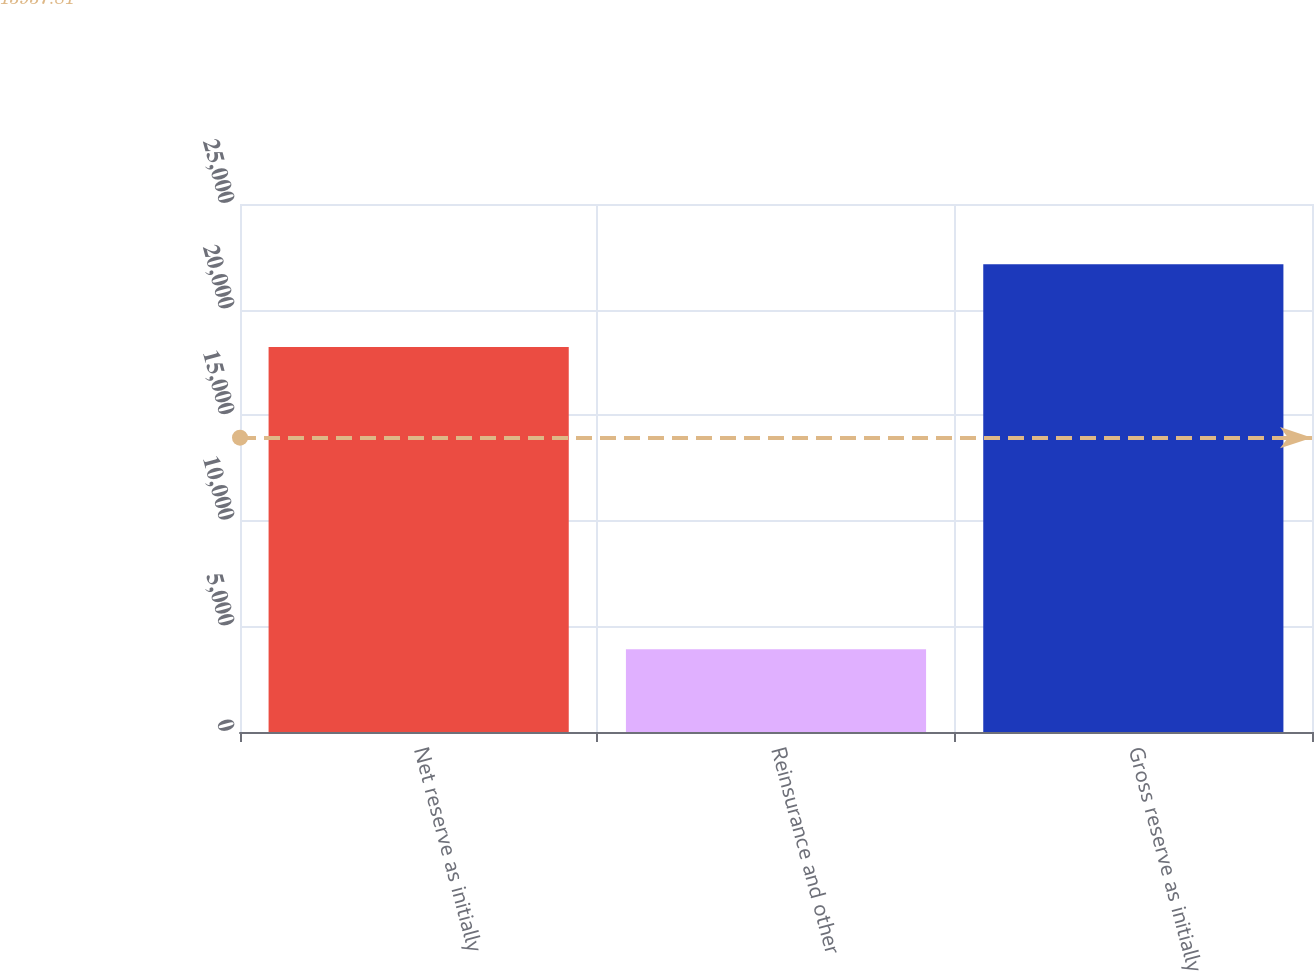Convert chart. <chart><loc_0><loc_0><loc_500><loc_500><bar_chart><fcel>Net reserve as initially<fcel>Reinsurance and other<fcel>Gross reserve as initially<nl><fcel>18231<fcel>3922<fcel>22153<nl></chart> 